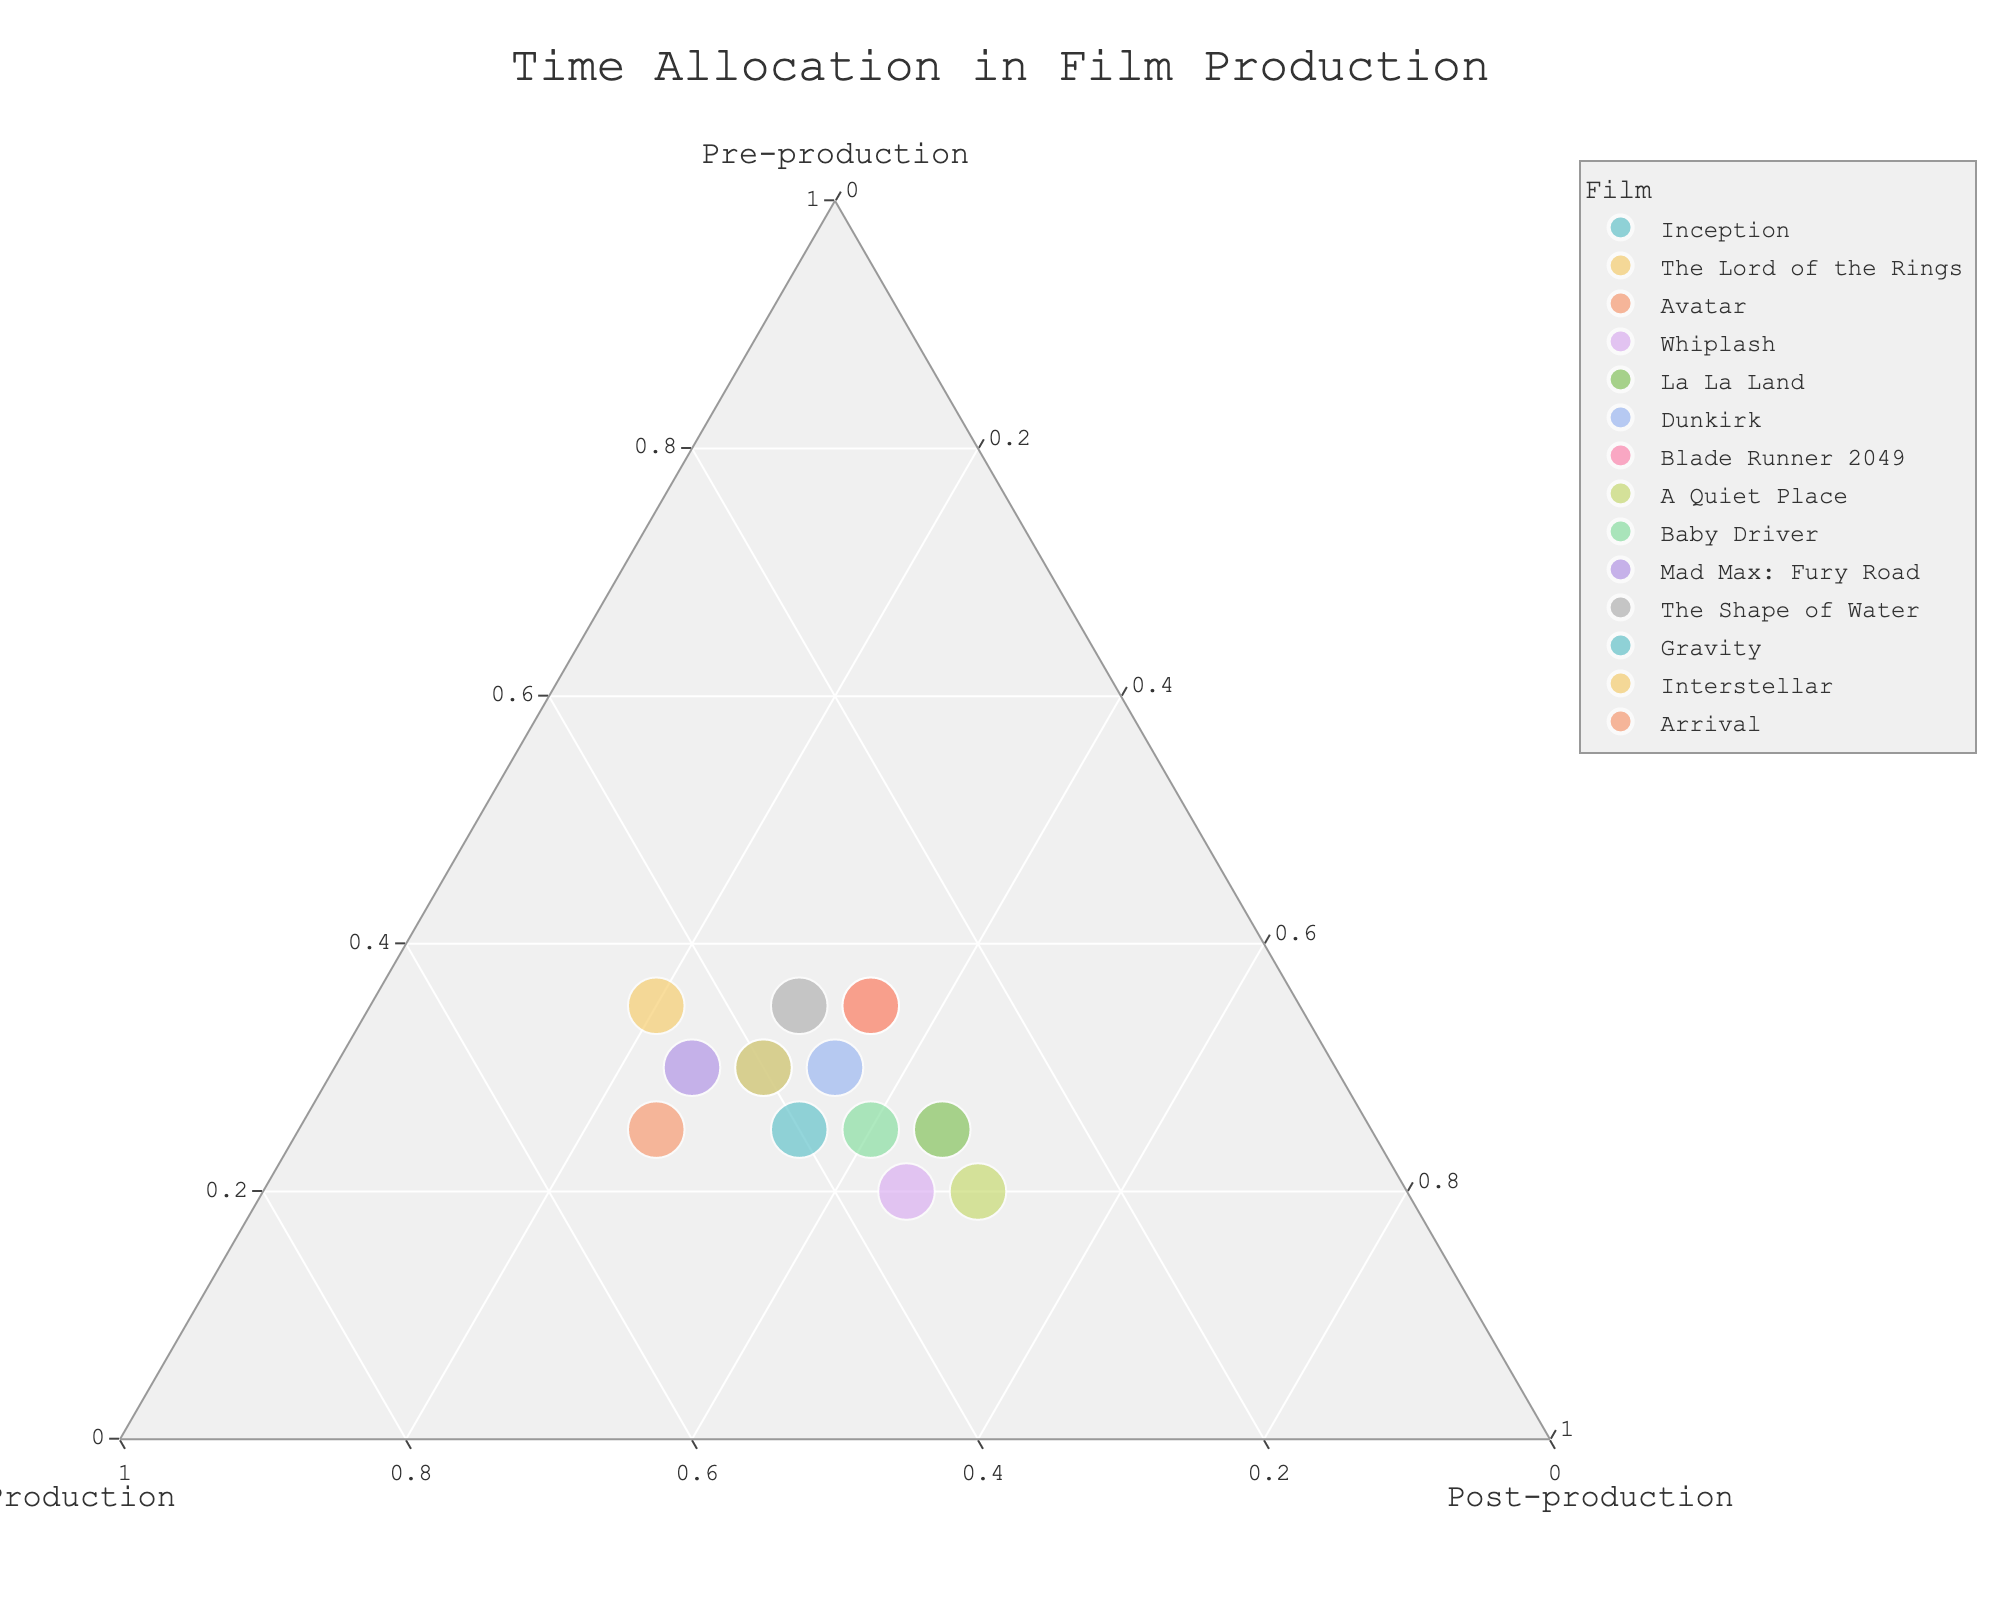What's the title of the figure? The title of the figure is at the top and is usually larger and bolder than other texts. This title summarizes the main topic of the chart.
Answer: Time Allocation in Film Production How many films allocate more than 40% of their time to post-production? To answer this, look at the "Post-production" axis and identify points that have a value greater than 0.4 or 40%.
Answer: Two films Which film has the highest allocation in pre-production? Identify the film positioned closest to the "Pre-production" axis's vertex. The higher the pre-production allocation, the closer the point will be to the Pre-production vertex.
Answer: The Shape of Water What's the average percentage of production time for the films? Calculate the mean of the "Production" percentage values from the data points provided.
Answer: 37.5% Which film equally allocates its time across the three phases? A point equidistant from all three vertices suggests an equal allocation. Find the point closest to the center of the ternary plot.
Answer: Dunkirk Comparing Blade Runner 2049 and Arrival, which one allocates more time to pre-production? Locate both films on the plot and compare their distance from the "Pre-production" vertex. The film closer to this vertex spends more time in pre-production.
Answer: Arrival What's the total sum of pre-production and production time for Gravity? Find the data point of Gravity and sum its pre-production and production values: 25% and 40%.
Answer: 65% Which film spends the least percentage of time in production? Locate the data points and compare their relative positions to the Production vertex. The furthest from this vertex has the smallest allocation.
Answer: La La Land How does Baby Driver’s post-production time compare to A Quiet Place’s? Compare their positions relative to the "Post-production" vertex. The closer point to this vertex indicates more time in post-production.
Answer: Baby Driver has less post-production time What’s the range of post-production times across all films? Identify the minimum and maximum post-production values from the data points and calculate the difference.
Answer: 20%-50% 